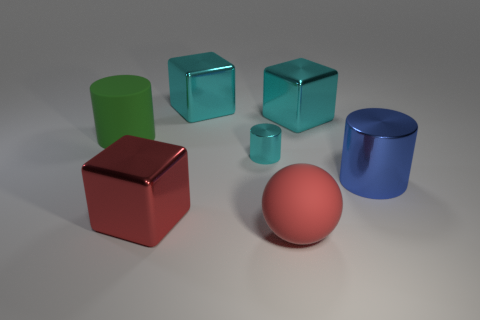There is a cylinder that is left of the ball and on the right side of the green matte cylinder; what color is it?
Your answer should be very brief. Cyan. What number of other things are there of the same color as the tiny thing?
Ensure brevity in your answer.  2. What is the large cylinder in front of the tiny cyan cylinder on the right side of the metal thing in front of the large metal cylinder made of?
Keep it short and to the point. Metal. How many cylinders are either large red metal things or large red matte objects?
Ensure brevity in your answer.  0. Are there any other things that are the same size as the red shiny object?
Make the answer very short. Yes. What number of large things are to the left of the metal cylinder that is left of the matte thing in front of the green cylinder?
Keep it short and to the point. 3. Does the red shiny thing have the same shape as the blue thing?
Keep it short and to the point. No. Is the cyan cube left of the red rubber object made of the same material as the large object that is on the left side of the big red block?
Provide a succinct answer. No. What number of objects are either objects that are to the right of the big green thing or large metal cubes that are behind the big metal cylinder?
Offer a very short reply. 6. Are there any other things that have the same shape as the tiny metallic object?
Make the answer very short. Yes. 